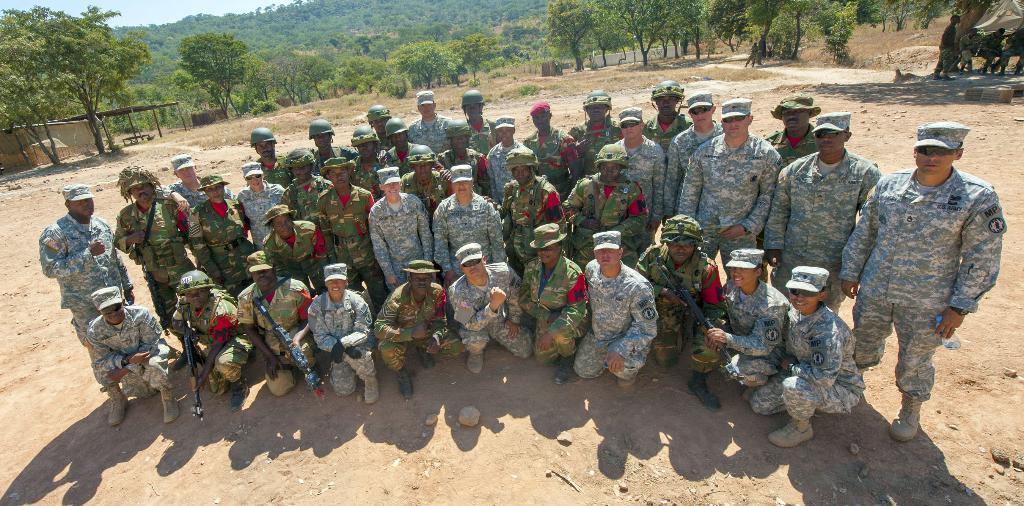In one or two sentences, can you explain what this image depicts? In this picture we can see some people standing and some people sitting in the front, some of these people wore helmets and some people wore caps, in the background there are trees, we can see the sky at the left top of the picture, at the bottom there are some stones. 